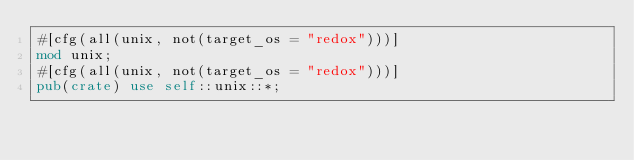<code> <loc_0><loc_0><loc_500><loc_500><_Rust_>#[cfg(all(unix, not(target_os = "redox")))]
mod unix;
#[cfg(all(unix, not(target_os = "redox")))]
pub(crate) use self::unix::*;
</code> 